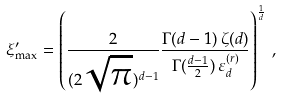Convert formula to latex. <formula><loc_0><loc_0><loc_500><loc_500>\xi ^ { \prime } _ { \max } = \left ( \frac { 2 } { ( 2 \sqrt { \pi } ) ^ { d - 1 } } \frac { \Gamma ( d - 1 ) \, \zeta ( d ) } { \Gamma ( \frac { d - 1 } { 2 } ) \, \varepsilon _ { d } ^ { ( r ) } } \right ) ^ { \frac { 1 } { d } } \, ,</formula> 